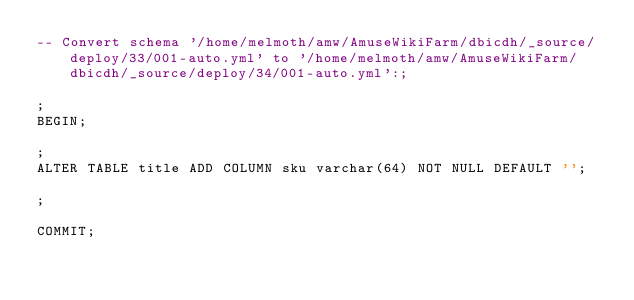Convert code to text. <code><loc_0><loc_0><loc_500><loc_500><_SQL_>-- Convert schema '/home/melmoth/amw/AmuseWikiFarm/dbicdh/_source/deploy/33/001-auto.yml' to '/home/melmoth/amw/AmuseWikiFarm/dbicdh/_source/deploy/34/001-auto.yml':;

;
BEGIN;

;
ALTER TABLE title ADD COLUMN sku varchar(64) NOT NULL DEFAULT '';

;

COMMIT;

</code> 